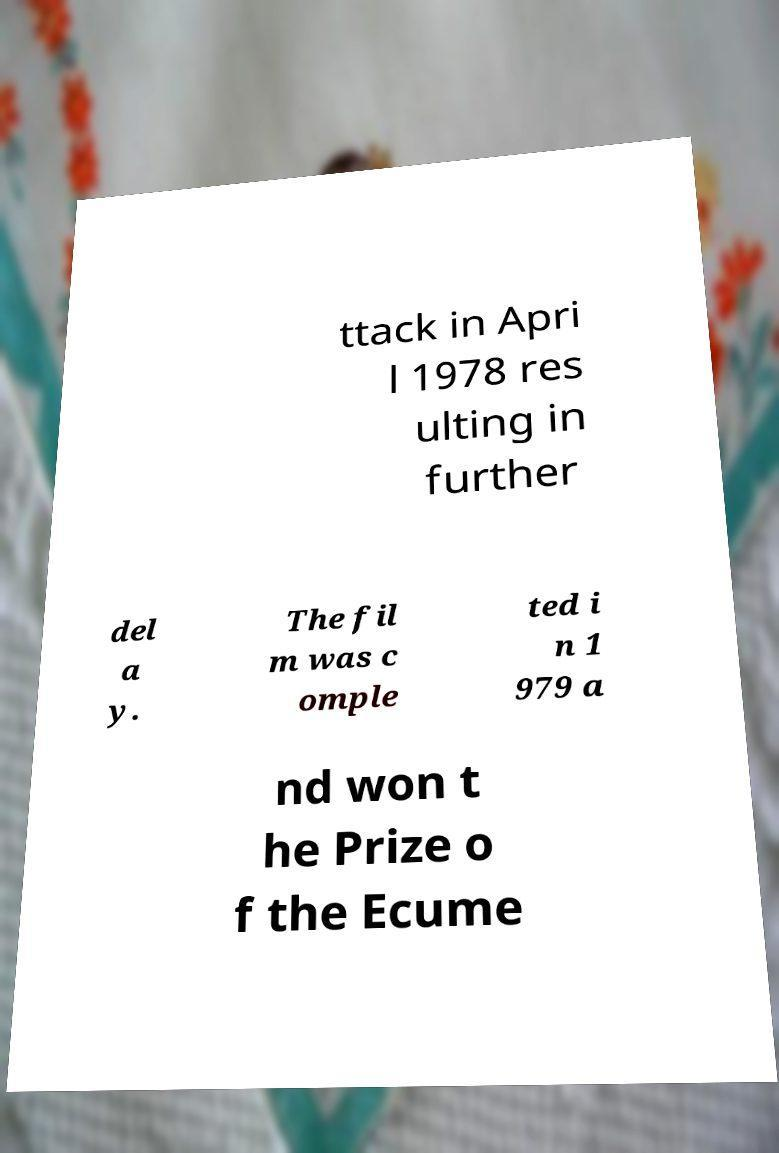I need the written content from this picture converted into text. Can you do that? ttack in Apri l 1978 res ulting in further del a y. The fil m was c omple ted i n 1 979 a nd won t he Prize o f the Ecume 